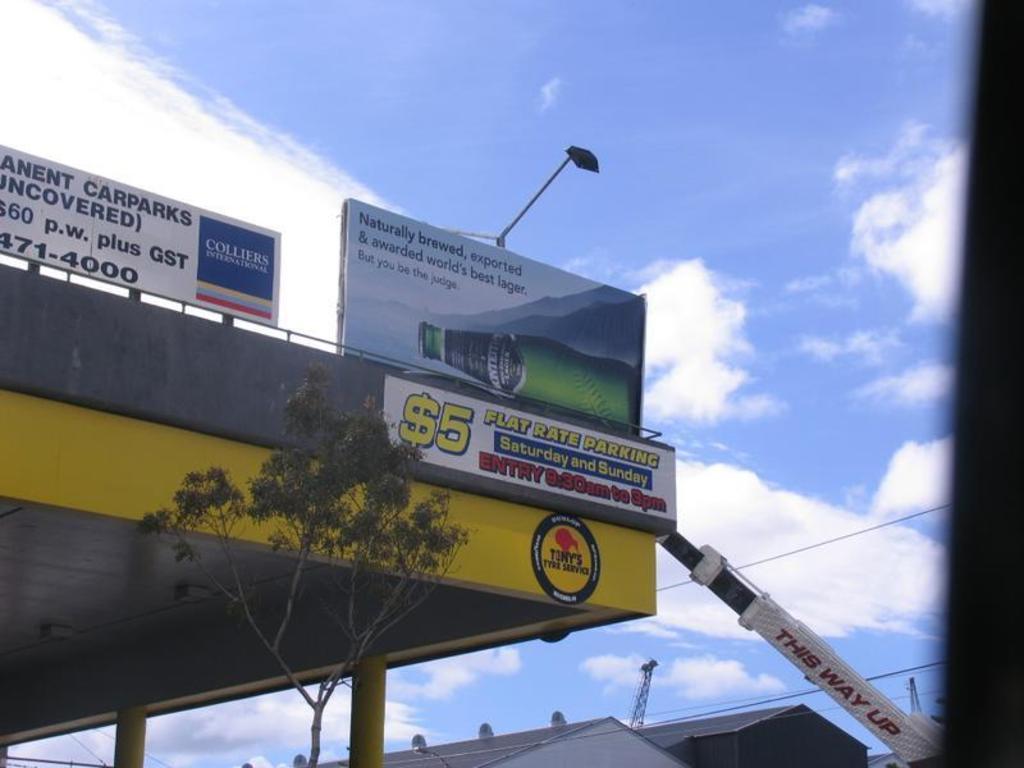What kind of rate is the parking?
Give a very brief answer. $5. Whats the parking name?
Keep it short and to the point. Flat rate parking. 